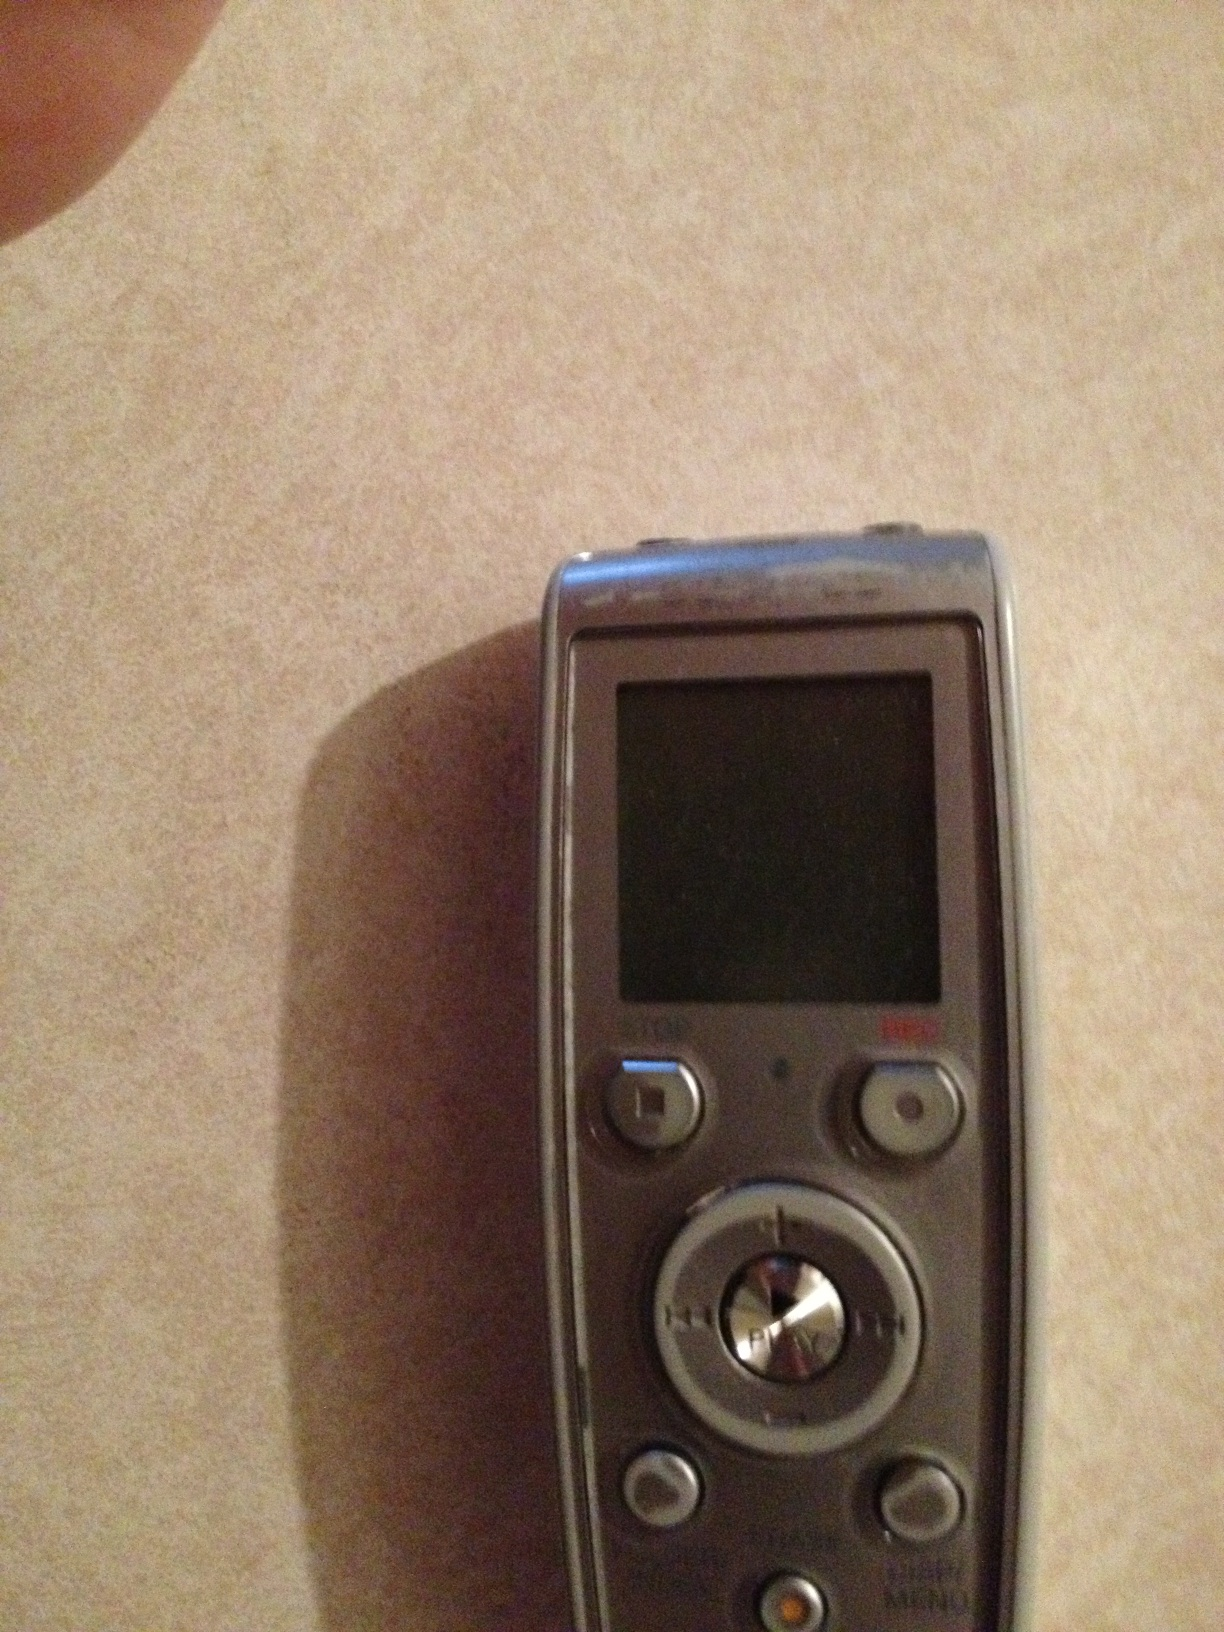Describe a scenario where this device might be critical in an unexpected situation. Imagine a journalist investigating a sensitive political story. They meet with a whistleblower who is nervous about speaking up. In this tense scenario, the journalist uses this digital voice recorder to capture the whistleblower's testimony discreetly and securely. This recorded audio becomes crucial evidence supporting the journalist's story, which could lead to unveiling significant truths. 